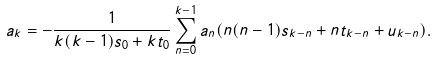<formula> <loc_0><loc_0><loc_500><loc_500>a _ { k } = - \frac { 1 } { k ( k - 1 ) s _ { 0 } + k t _ { 0 } } \sum _ { n = 0 } ^ { k - 1 } a _ { n } ( n ( n - 1 ) s _ { k - n } + n t _ { k - n } + u _ { k - n } ) .</formula> 